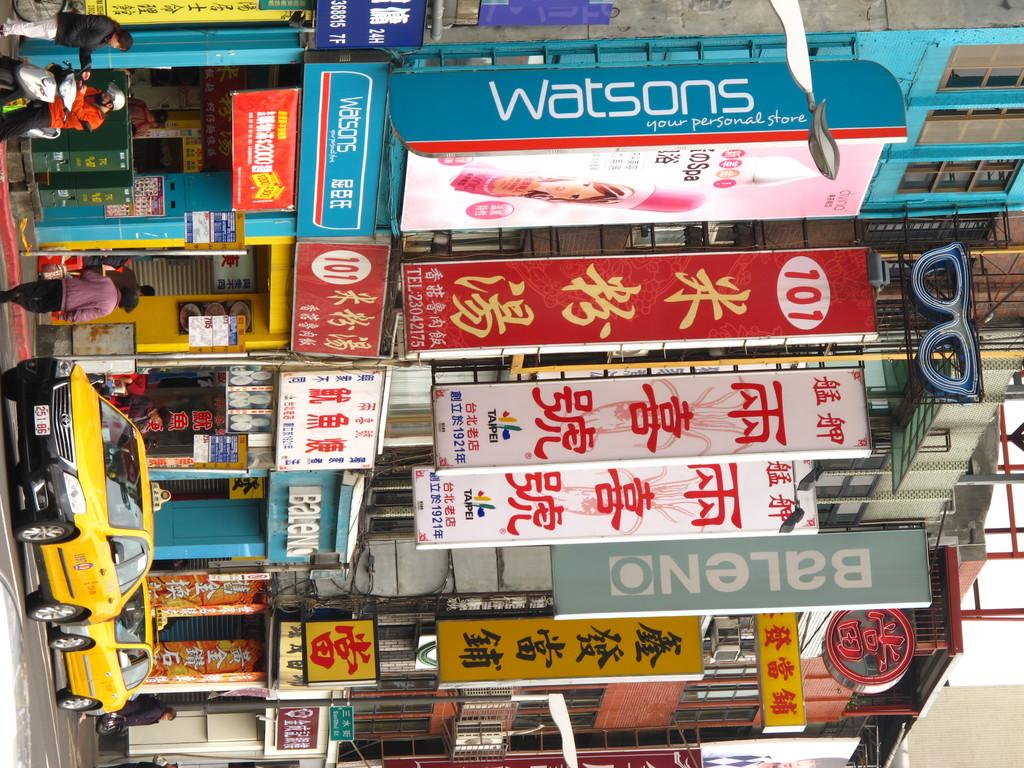<image>
Create a compact narrative representing the image presented. A store called Watsons Your personal Store has two yellow taxis sitting in front 